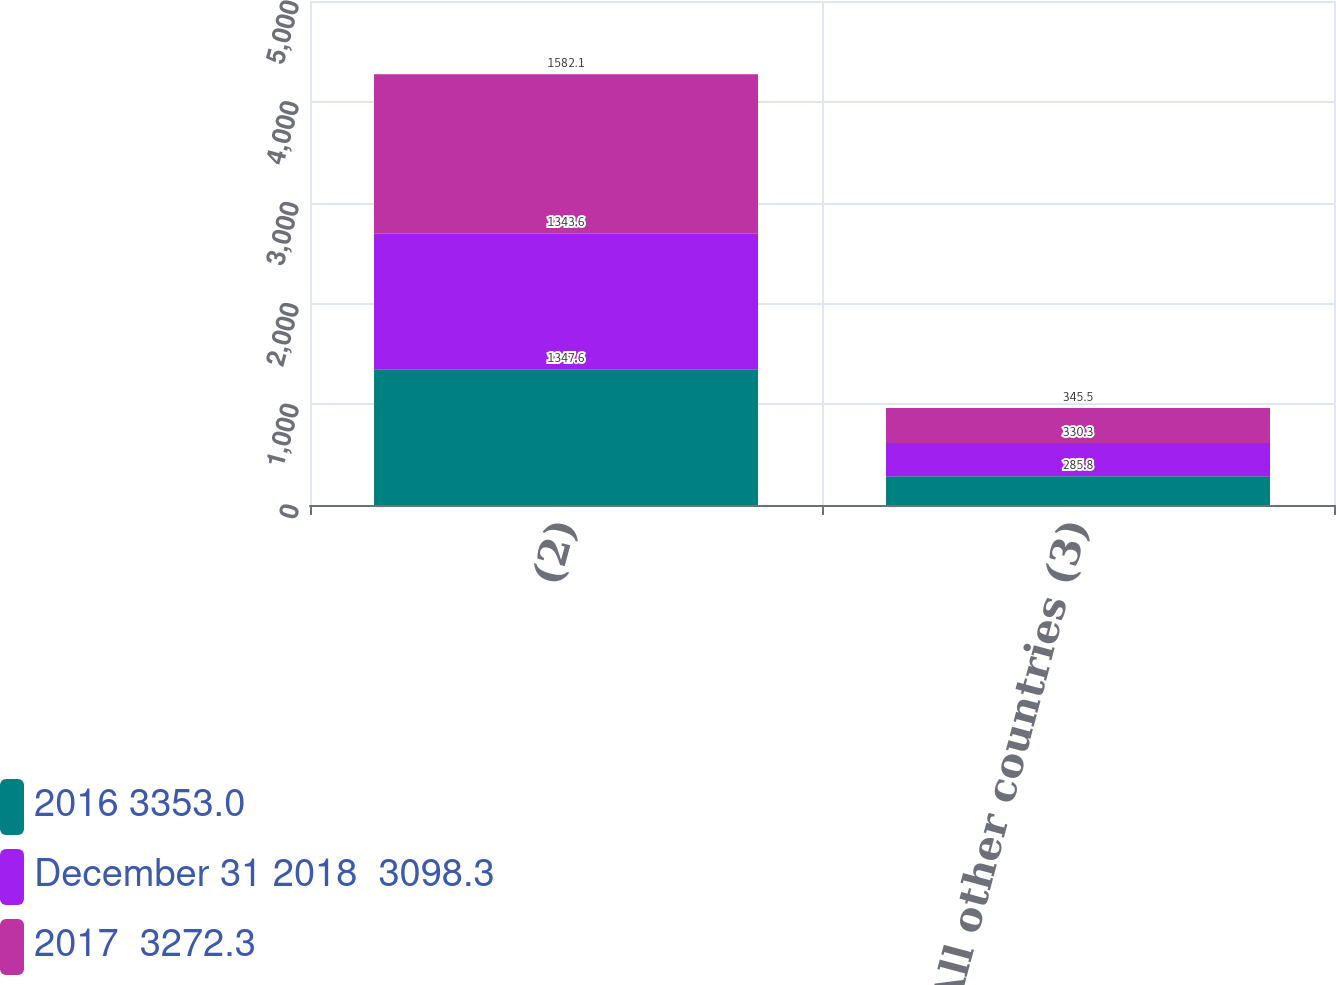Convert chart. <chart><loc_0><loc_0><loc_500><loc_500><stacked_bar_chart><ecel><fcel>(2)<fcel>Europe All other countries (3)<nl><fcel>2016 3353.0<fcel>1347.6<fcel>285.8<nl><fcel>December 31 2018  3098.3<fcel>1343.6<fcel>330.3<nl><fcel>2017  3272.3<fcel>1582.1<fcel>345.5<nl></chart> 